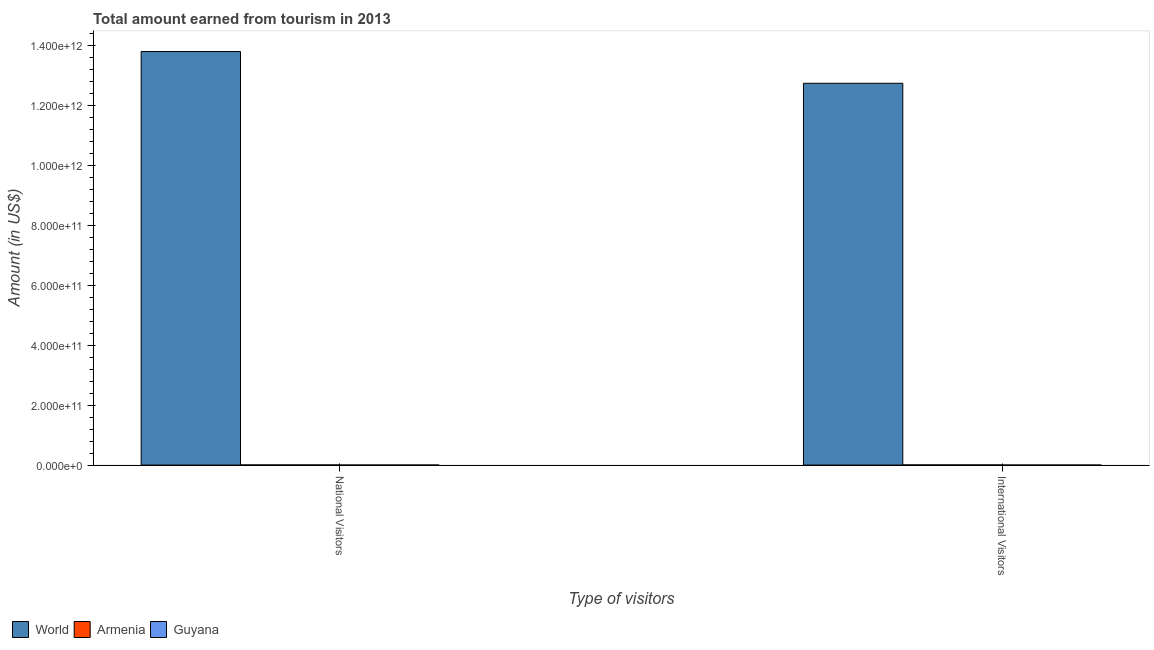How many groups of bars are there?
Give a very brief answer. 2. How many bars are there on the 1st tick from the left?
Keep it short and to the point. 3. How many bars are there on the 2nd tick from the right?
Keep it short and to the point. 3. What is the label of the 1st group of bars from the left?
Provide a succinct answer. National Visitors. What is the amount earned from national visitors in World?
Make the answer very short. 1.38e+12. Across all countries, what is the maximum amount earned from national visitors?
Provide a succinct answer. 1.38e+12. Across all countries, what is the minimum amount earned from national visitors?
Provide a succinct answer. 7.70e+07. In which country was the amount earned from national visitors minimum?
Make the answer very short. Guyana. What is the total amount earned from national visitors in the graph?
Provide a succinct answer. 1.38e+12. What is the difference between the amount earned from international visitors in World and that in Guyana?
Make the answer very short. 1.27e+12. What is the difference between the amount earned from national visitors in Armenia and the amount earned from international visitors in World?
Ensure brevity in your answer.  -1.27e+12. What is the average amount earned from national visitors per country?
Give a very brief answer. 4.61e+11. What is the difference between the amount earned from national visitors and amount earned from international visitors in World?
Provide a short and direct response. 1.06e+11. What is the ratio of the amount earned from international visitors in Armenia to that in Guyana?
Ensure brevity in your answer.  7.15. What does the 2nd bar from the left in National Visitors represents?
Offer a very short reply. Armenia. How many countries are there in the graph?
Ensure brevity in your answer.  3. What is the difference between two consecutive major ticks on the Y-axis?
Your response must be concise. 2.00e+11. Are the values on the major ticks of Y-axis written in scientific E-notation?
Offer a terse response. Yes. How are the legend labels stacked?
Provide a succinct answer. Horizontal. What is the title of the graph?
Offer a very short reply. Total amount earned from tourism in 2013. Does "Bolivia" appear as one of the legend labels in the graph?
Ensure brevity in your answer.  No. What is the label or title of the X-axis?
Offer a very short reply. Type of visitors. What is the label or title of the Y-axis?
Keep it short and to the point. Amount (in US$). What is the Amount (in US$) of World in National Visitors?
Your answer should be compact. 1.38e+12. What is the Amount (in US$) in Armenia in National Visitors?
Make the answer very short. 4.75e+08. What is the Amount (in US$) in Guyana in National Visitors?
Offer a very short reply. 7.70e+07. What is the Amount (in US$) in World in International Visitors?
Make the answer very short. 1.27e+12. What is the Amount (in US$) of Armenia in International Visitors?
Offer a very short reply. 5.79e+08. What is the Amount (in US$) of Guyana in International Visitors?
Offer a very short reply. 8.10e+07. Across all Type of visitors, what is the maximum Amount (in US$) of World?
Give a very brief answer. 1.38e+12. Across all Type of visitors, what is the maximum Amount (in US$) of Armenia?
Keep it short and to the point. 5.79e+08. Across all Type of visitors, what is the maximum Amount (in US$) of Guyana?
Your answer should be compact. 8.10e+07. Across all Type of visitors, what is the minimum Amount (in US$) of World?
Make the answer very short. 1.27e+12. Across all Type of visitors, what is the minimum Amount (in US$) of Armenia?
Your answer should be compact. 4.75e+08. Across all Type of visitors, what is the minimum Amount (in US$) in Guyana?
Make the answer very short. 7.70e+07. What is the total Amount (in US$) in World in the graph?
Your response must be concise. 2.66e+12. What is the total Amount (in US$) of Armenia in the graph?
Make the answer very short. 1.05e+09. What is the total Amount (in US$) in Guyana in the graph?
Your response must be concise. 1.58e+08. What is the difference between the Amount (in US$) of World in National Visitors and that in International Visitors?
Provide a short and direct response. 1.06e+11. What is the difference between the Amount (in US$) of Armenia in National Visitors and that in International Visitors?
Your answer should be compact. -1.04e+08. What is the difference between the Amount (in US$) of Guyana in National Visitors and that in International Visitors?
Provide a succinct answer. -4.00e+06. What is the difference between the Amount (in US$) of World in National Visitors and the Amount (in US$) of Armenia in International Visitors?
Keep it short and to the point. 1.38e+12. What is the difference between the Amount (in US$) in World in National Visitors and the Amount (in US$) in Guyana in International Visitors?
Your answer should be very brief. 1.38e+12. What is the difference between the Amount (in US$) of Armenia in National Visitors and the Amount (in US$) of Guyana in International Visitors?
Provide a succinct answer. 3.94e+08. What is the average Amount (in US$) in World per Type of visitors?
Provide a short and direct response. 1.33e+12. What is the average Amount (in US$) of Armenia per Type of visitors?
Ensure brevity in your answer.  5.27e+08. What is the average Amount (in US$) of Guyana per Type of visitors?
Your answer should be very brief. 7.90e+07. What is the difference between the Amount (in US$) in World and Amount (in US$) in Armenia in National Visitors?
Your answer should be very brief. 1.38e+12. What is the difference between the Amount (in US$) in World and Amount (in US$) in Guyana in National Visitors?
Your answer should be very brief. 1.38e+12. What is the difference between the Amount (in US$) in Armenia and Amount (in US$) in Guyana in National Visitors?
Keep it short and to the point. 3.98e+08. What is the difference between the Amount (in US$) in World and Amount (in US$) in Armenia in International Visitors?
Provide a short and direct response. 1.27e+12. What is the difference between the Amount (in US$) in World and Amount (in US$) in Guyana in International Visitors?
Your answer should be very brief. 1.27e+12. What is the difference between the Amount (in US$) of Armenia and Amount (in US$) of Guyana in International Visitors?
Ensure brevity in your answer.  4.98e+08. What is the ratio of the Amount (in US$) of Armenia in National Visitors to that in International Visitors?
Give a very brief answer. 0.82. What is the ratio of the Amount (in US$) in Guyana in National Visitors to that in International Visitors?
Provide a short and direct response. 0.95. What is the difference between the highest and the second highest Amount (in US$) of World?
Your answer should be very brief. 1.06e+11. What is the difference between the highest and the second highest Amount (in US$) of Armenia?
Give a very brief answer. 1.04e+08. What is the difference between the highest and the second highest Amount (in US$) of Guyana?
Provide a succinct answer. 4.00e+06. What is the difference between the highest and the lowest Amount (in US$) in World?
Ensure brevity in your answer.  1.06e+11. What is the difference between the highest and the lowest Amount (in US$) in Armenia?
Your response must be concise. 1.04e+08. 